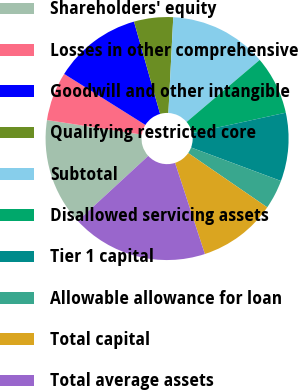Convert chart to OTSL. <chart><loc_0><loc_0><loc_500><loc_500><pie_chart><fcel>Shareholders' equity<fcel>Losses in other comprehensive<fcel>Goodwill and other intangible<fcel>Qualifying restricted core<fcel>Subtotal<fcel>Disallowed servicing assets<fcel>Tier 1 capital<fcel>Allowable allowance for loan<fcel>Total capital<fcel>Total average assets<nl><fcel>14.29%<fcel>6.49%<fcel>11.69%<fcel>5.2%<fcel>12.99%<fcel>7.79%<fcel>9.09%<fcel>3.9%<fcel>10.39%<fcel>18.18%<nl></chart> 